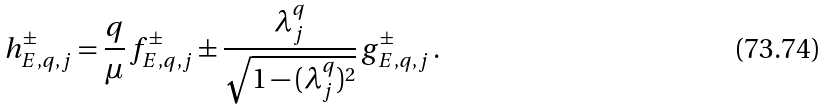<formula> <loc_0><loc_0><loc_500><loc_500>h ^ { \pm } _ { E , q , j } = \frac { q } { \mu } \, f ^ { \pm } _ { E , q , j } \pm \frac { \lambda ^ { q } _ { j } } { \sqrt { 1 - ( \lambda ^ { q } _ { j } ) ^ { 2 } } } \, g ^ { \pm } _ { E , q , j } \, .</formula> 